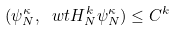Convert formula to latex. <formula><loc_0><loc_0><loc_500><loc_500>( \psi _ { N } ^ { \kappa } , \ w t H _ { N } ^ { k } \psi _ { N } ^ { \kappa } ) \leq C ^ { k }</formula> 